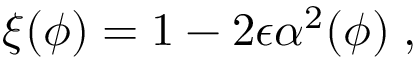<formula> <loc_0><loc_0><loc_500><loc_500>\xi ( \phi ) = 1 - 2 \epsilon \alpha ^ { 2 } ( \phi ) \, ,</formula> 